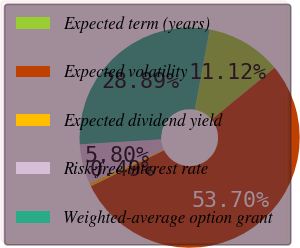Convert chart. <chart><loc_0><loc_0><loc_500><loc_500><pie_chart><fcel>Expected term (years)<fcel>Expected volatility<fcel>Expected dividend yield<fcel>Risk-free interest rate<fcel>Weighted-average option grant<nl><fcel>11.12%<fcel>53.7%<fcel>0.49%<fcel>5.8%<fcel>28.89%<nl></chart> 